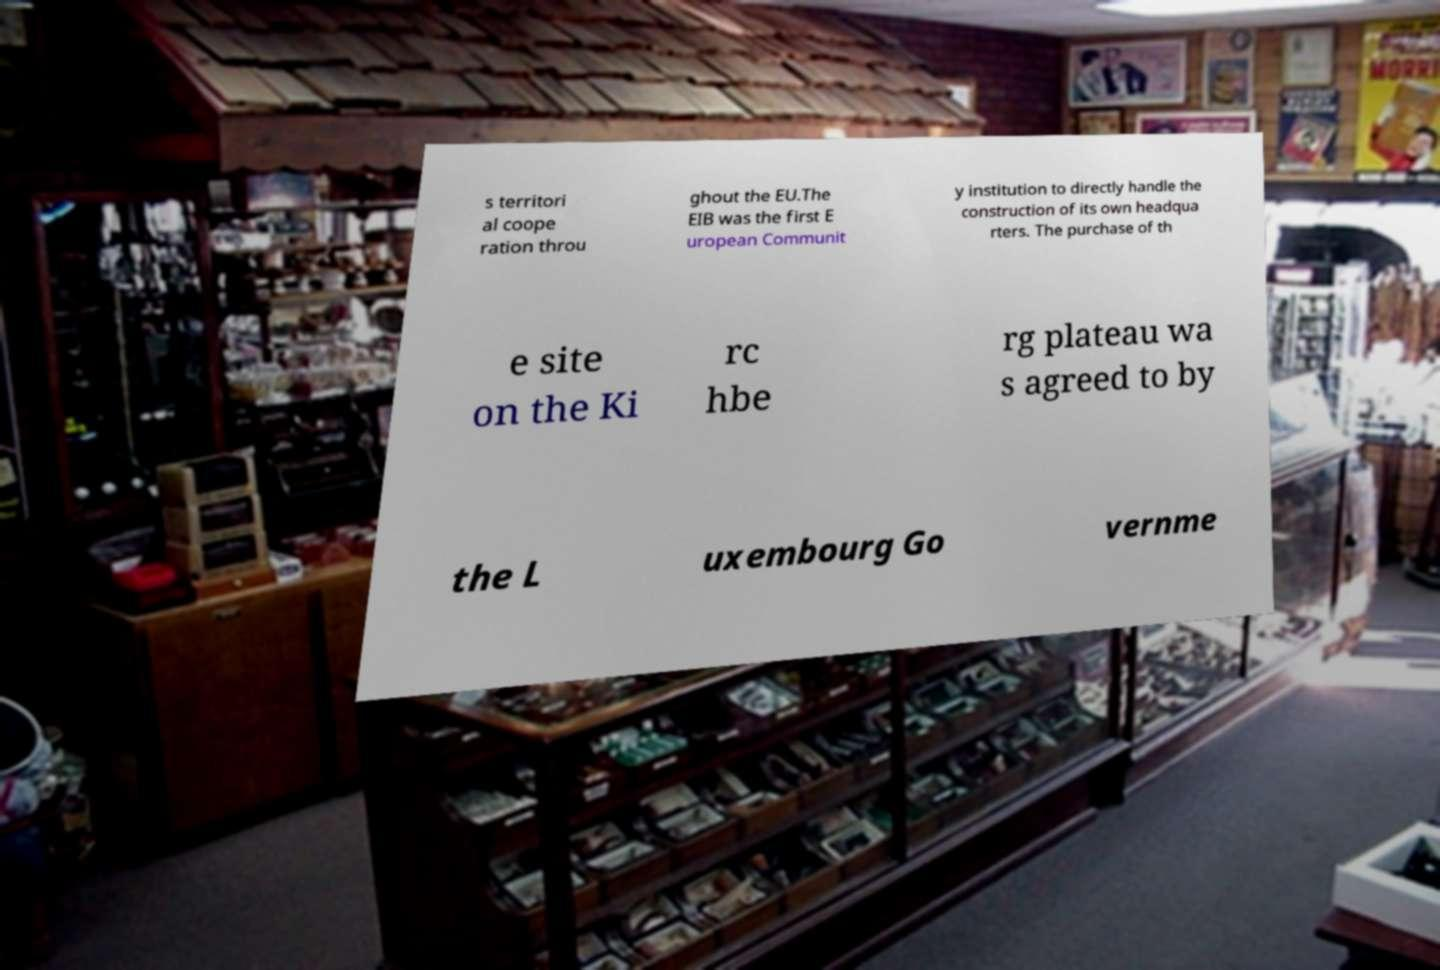Could you assist in decoding the text presented in this image and type it out clearly? s territori al coope ration throu ghout the EU.The EIB was the first E uropean Communit y institution to directly handle the construction of its own headqua rters. The purchase of th e site on the Ki rc hbe rg plateau wa s agreed to by the L uxembourg Go vernme 